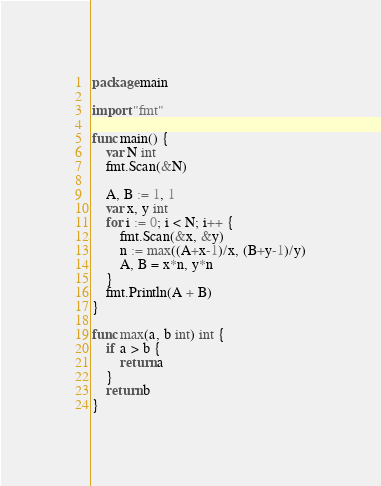Convert code to text. <code><loc_0><loc_0><loc_500><loc_500><_Go_>package main

import "fmt"

func main() {
	var N int
	fmt.Scan(&N)

	A, B := 1, 1
	var x, y int
	for i := 0; i < N; i++ {
		fmt.Scan(&x, &y)
		n := max((A+x-1)/x, (B+y-1)/y)
		A, B = x*n, y*n
	}
	fmt.Println(A + B)
}

func max(a, b int) int {
	if a > b {
		return a
	}
	return b
}
</code> 